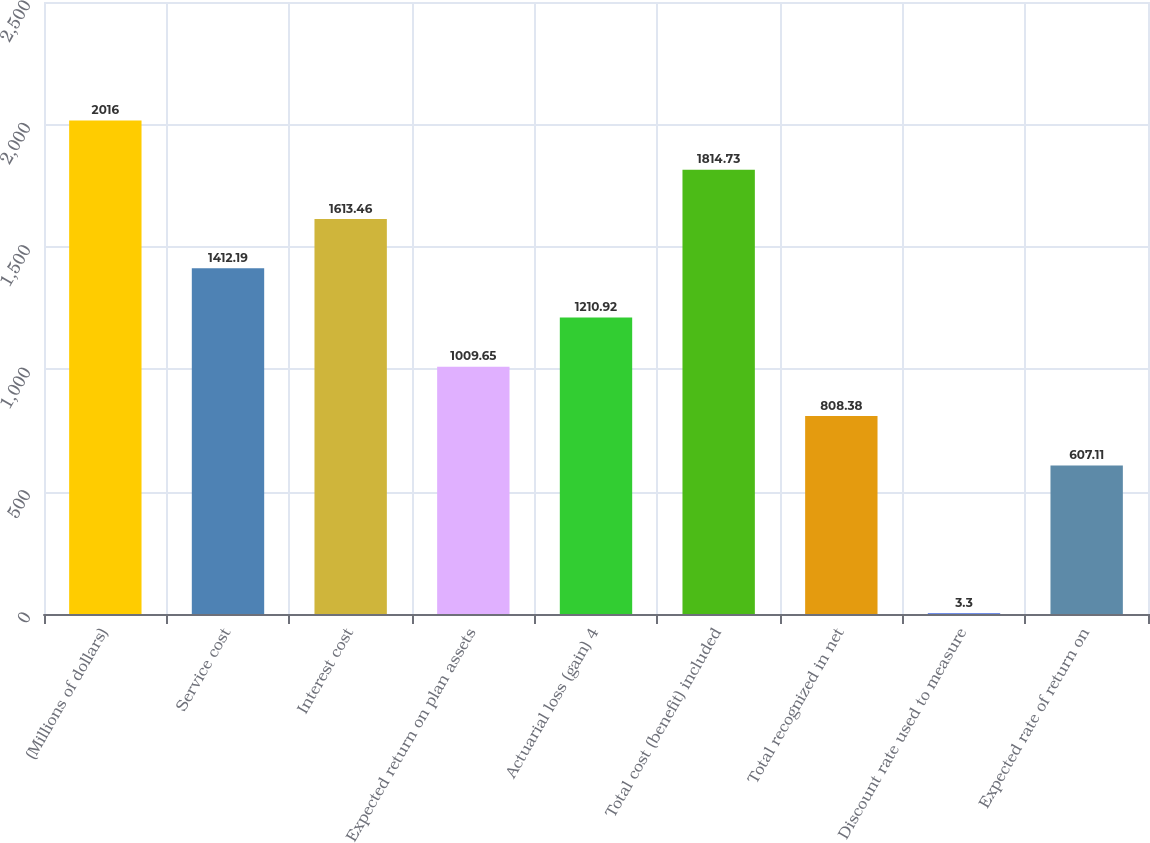<chart> <loc_0><loc_0><loc_500><loc_500><bar_chart><fcel>(Millions of dollars)<fcel>Service cost<fcel>Interest cost<fcel>Expected return on plan assets<fcel>Actuarial loss (gain) 4<fcel>Total cost (benefit) included<fcel>Total recognized in net<fcel>Discount rate used to measure<fcel>Expected rate of return on<nl><fcel>2016<fcel>1412.19<fcel>1613.46<fcel>1009.65<fcel>1210.92<fcel>1814.73<fcel>808.38<fcel>3.3<fcel>607.11<nl></chart> 